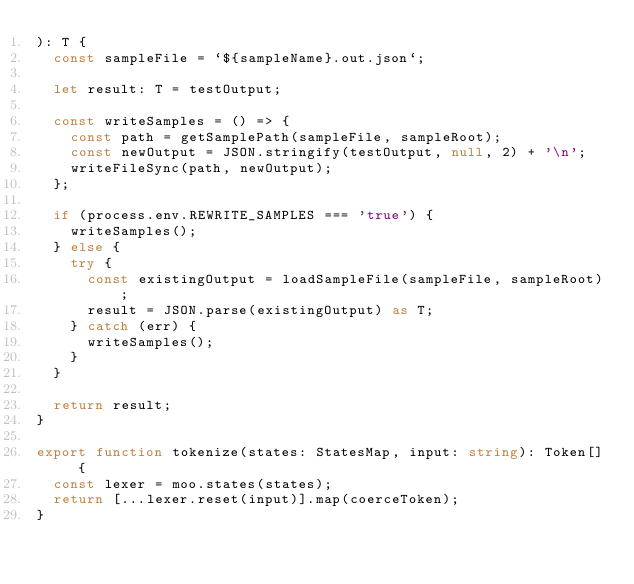<code> <loc_0><loc_0><loc_500><loc_500><_TypeScript_>): T {
  const sampleFile = `${sampleName}.out.json`;

  let result: T = testOutput;

  const writeSamples = () => {
    const path = getSamplePath(sampleFile, sampleRoot);
    const newOutput = JSON.stringify(testOutput, null, 2) + '\n';
    writeFileSync(path, newOutput);
  };

  if (process.env.REWRITE_SAMPLES === 'true') {
    writeSamples();
  } else {
    try {
      const existingOutput = loadSampleFile(sampleFile, sampleRoot);
      result = JSON.parse(existingOutput) as T;
    } catch (err) {
      writeSamples();
    }
  }

  return result;
}

export function tokenize(states: StatesMap, input: string): Token[] {
  const lexer = moo.states(states);
  return [...lexer.reset(input)].map(coerceToken);
}
</code> 